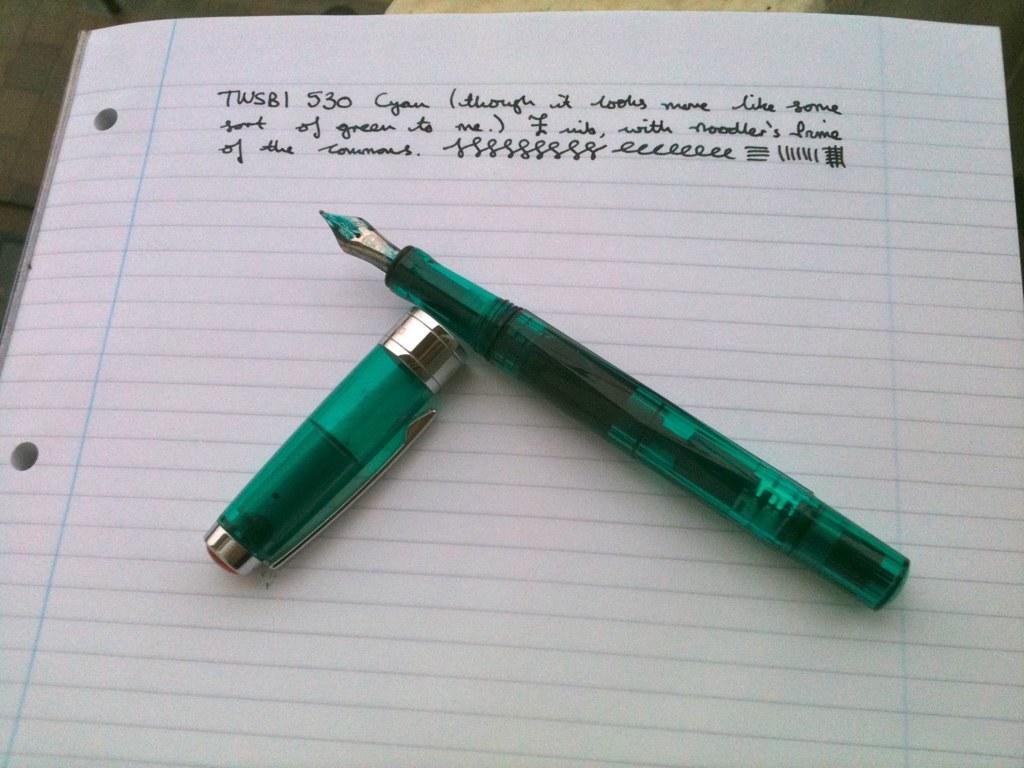How would you summarize this image in a sentence or two? In this image we can see a book on which there is a pen which is in green color and there are some words written in it. 